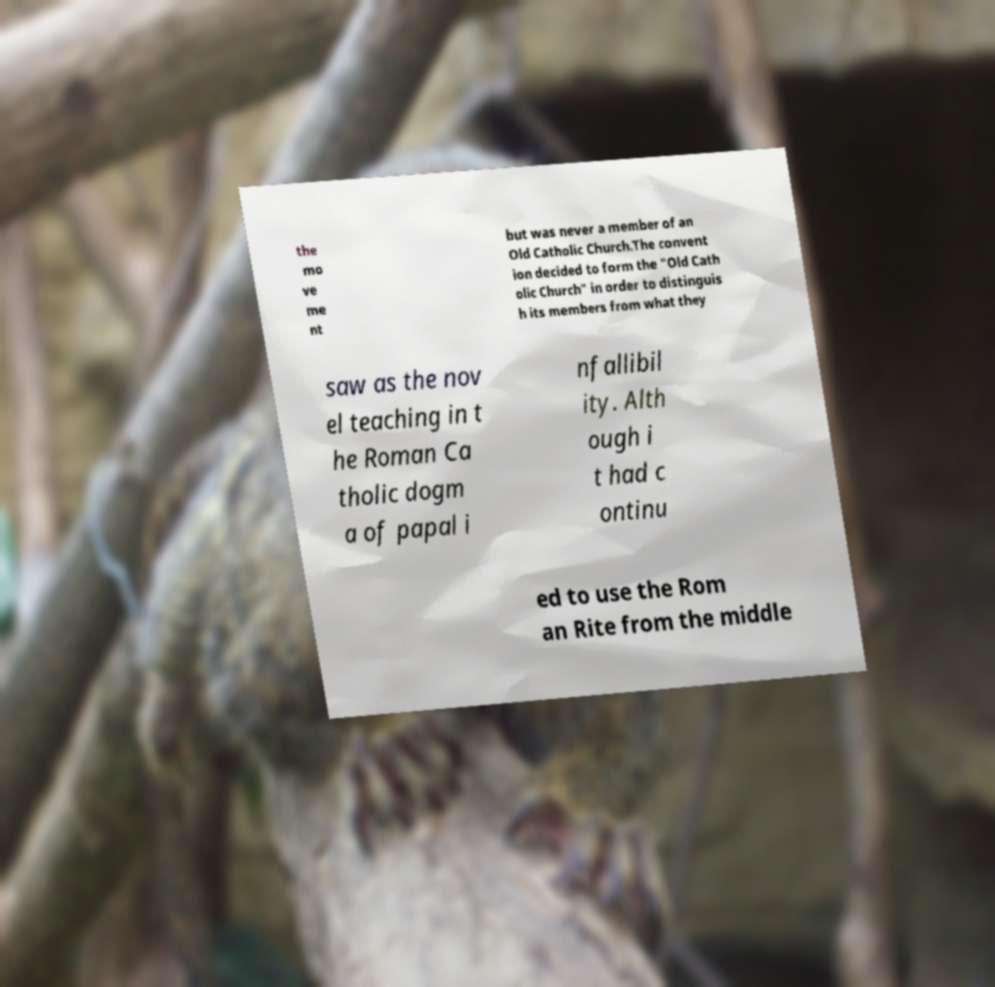For documentation purposes, I need the text within this image transcribed. Could you provide that? the mo ve me nt but was never a member of an Old Catholic Church.The convent ion decided to form the "Old Cath olic Church" in order to distinguis h its members from what they saw as the nov el teaching in t he Roman Ca tholic dogm a of papal i nfallibil ity. Alth ough i t had c ontinu ed to use the Rom an Rite from the middle 